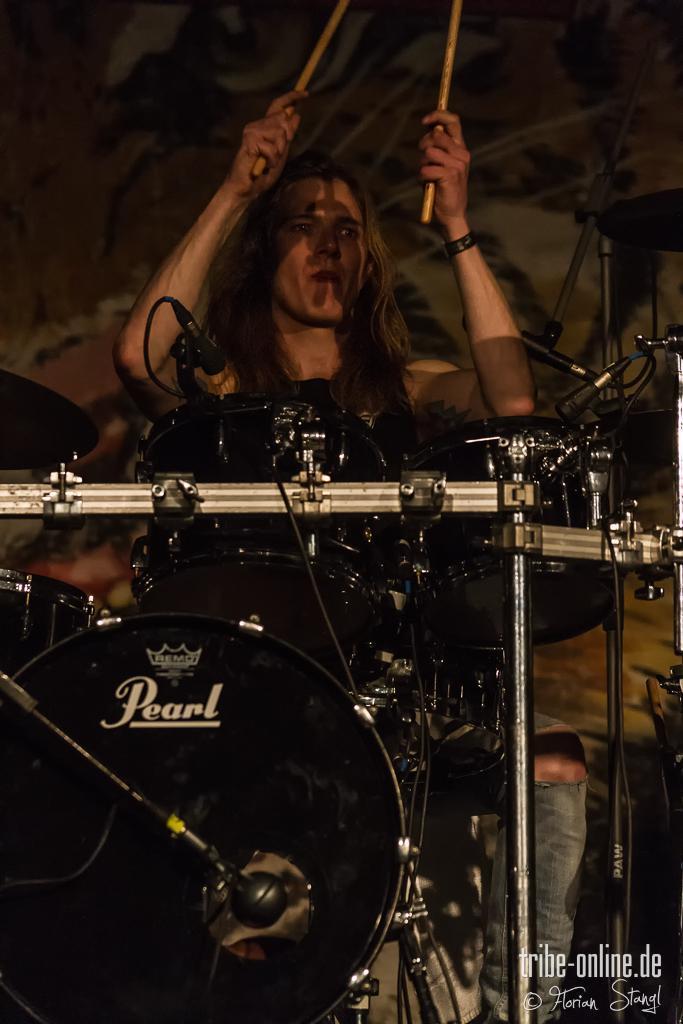Who is the main subject in the image? There is a woman in the image. Where is the woman located in the image? The woman is in the middle of the image. What is the woman holding in her hands? The woman is holding drumsticks in her hands. What musical instrument can be seen in the image? There is a snare drum musical instrument in the image. What type of berry is the woman holding in her hands? The woman is not holding a berry in her hands; she is holding drumsticks. Can you see any seeds in the image? There are no seeds visible in the image. 